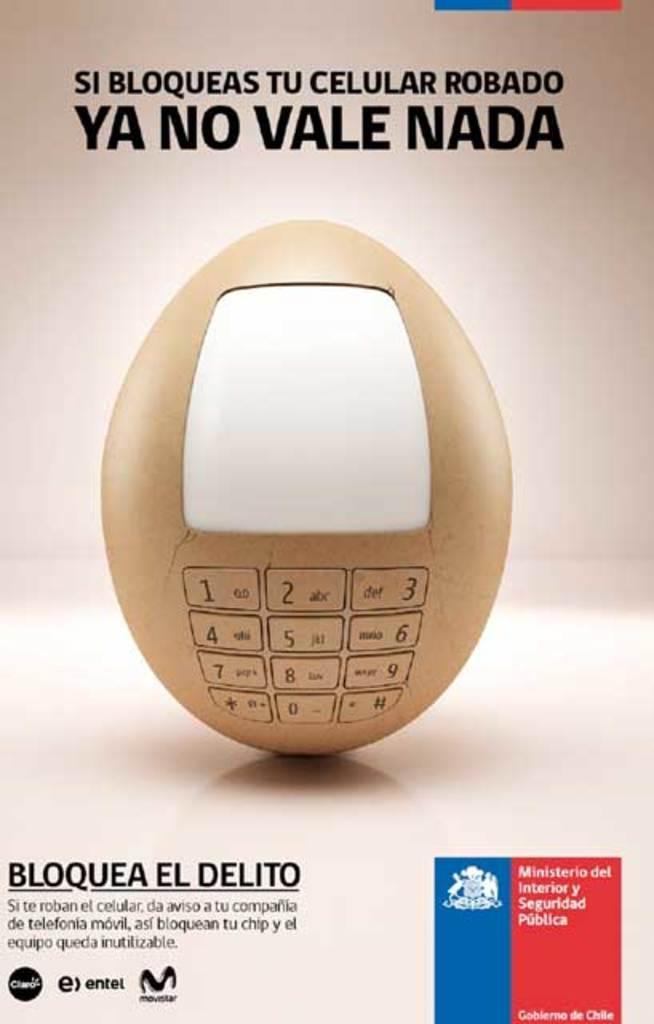Please provide a concise description of this image. In this image I see the depiction of an egg and I see something is written over here and I see the watermark on the bottom and on the top and I see the logo over here and I see something is written over here too. 